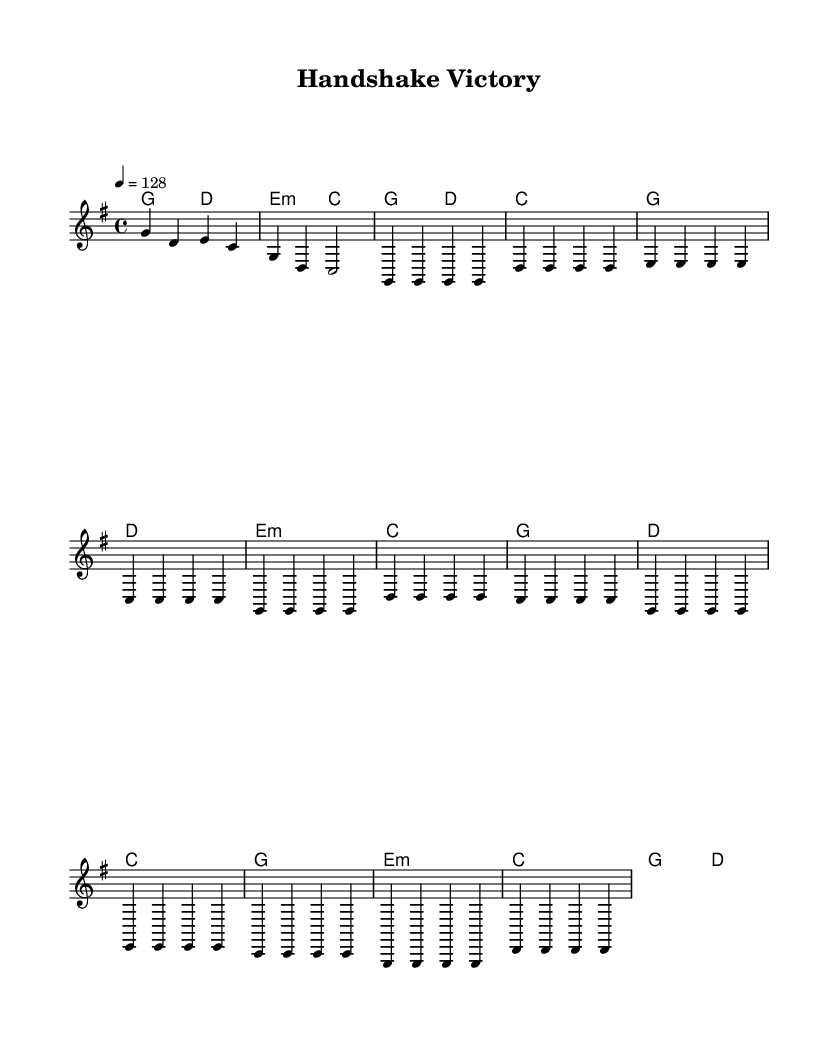What is the key signature of this music? The key signature shown at the beginning of the score indicates one sharp, which corresponds to G major.
Answer: G major What is the time signature of this music? The time signature shown at the beginning is 4/4, meaning there are four beats in each measure and the quarter note gets one beat.
Answer: 4/4 What is the tempo marking? The tempo marking indicates a tempo of 128 beats per minute, which creates an upbeat feel suitable for Country Rock.
Answer: 128 How many measures are in the intro section? The intro consists of a total of two measures, as indicated by the notation and spacing on the score.
Answer: 2 What is the first chord in the piece? The first chord indicated in the harmony section is G major, shown at the beginning of the score.
Answer: G What is the mood conveyed by the melodies in the verse? The melodies in the verse primarily consist of repeated notes, creating an uplifting and celebratory mood, which is typical for Country Rock songs that celebrate success.
Answer: Uplifting What is the relationship between the chorus and the verse sections? The chorus follows the verse and shares similar melodic contours, emphasizing the celebratory theme of the song, and reinforces the overall structure typical in Country Rock music.
Answer: Similar melodic contours 